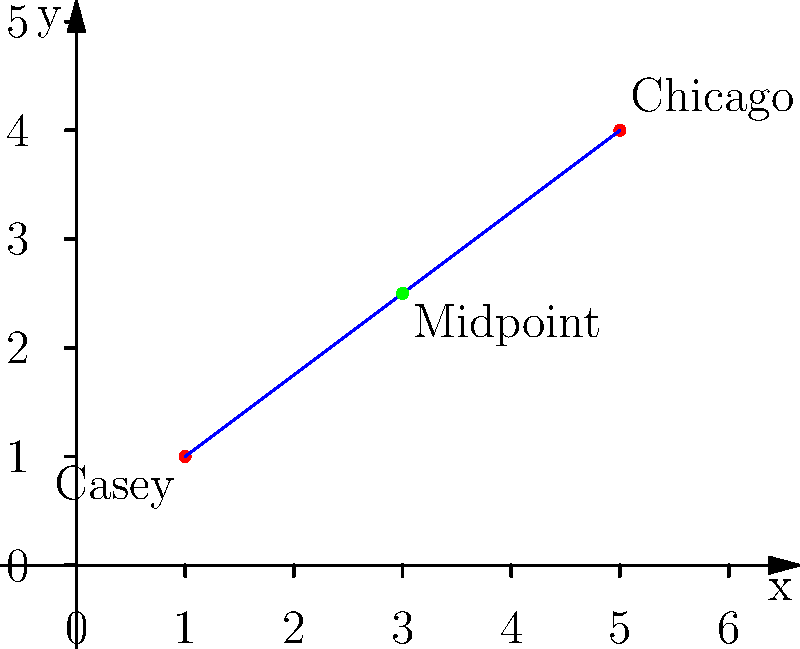As a frequent business traveler from Casey, Illinois, you're planning a flight to Chicago. On a coordinate plane, Casey is represented by the point $(1,1)$ and Chicago by $(5,4)$. What are the coordinates of the midpoint of your flight path? To find the midpoint of a line segment, we can use the midpoint formula:

$$ \text{Midpoint} = (\frac{x_1 + x_2}{2}, \frac{y_1 + y_2}{2}) $$

Where $(x_1, y_1)$ is the first point and $(x_2, y_2)$ is the second point.

1. Identify the coordinates:
   Casey: $(x_1, y_1) = (1, 1)$
   Chicago: $(x_2, y_2) = (5, 4)$

2. Apply the midpoint formula:
   $x$-coordinate: $\frac{x_1 + x_2}{2} = \frac{1 + 5}{2} = \frac{6}{2} = 3$
   $y$-coordinate: $\frac{y_1 + y_2}{2} = \frac{1 + 4}{2} = \frac{5}{2} = 2.5$

3. Combine the results:
   Midpoint = $(3, 2.5)$

This point represents the halfway point of your flight path between Casey and Chicago.
Answer: $(3, 2.5)$ 